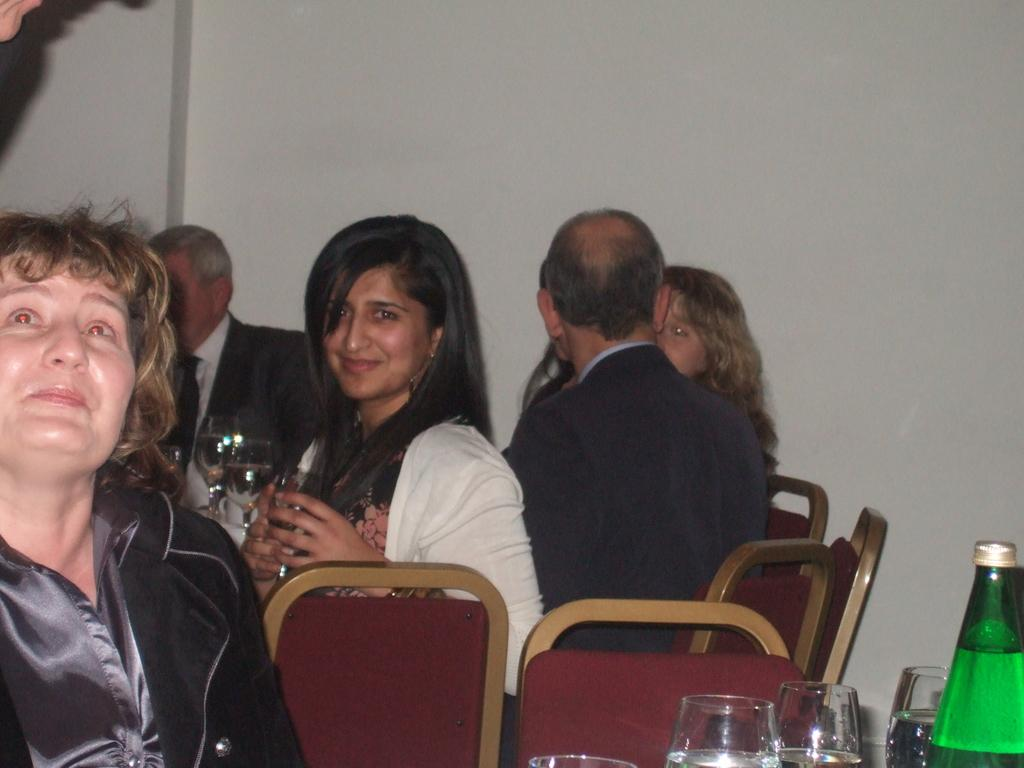What are the people in the image doing? There are persons sitting on chairs in the image. What objects are on the table in the image? There are glasses on a table in the image. What can be seen in the background of the image? There is a bottle and a wall visible in the background of the image. What is the purpose of the butter in the image? There is no butter present in the image, so its purpose cannot be determined. 